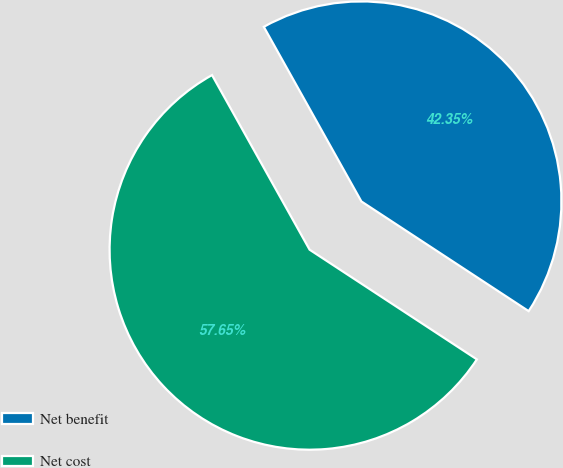<chart> <loc_0><loc_0><loc_500><loc_500><pie_chart><fcel>Net benefit<fcel>Net cost<nl><fcel>42.35%<fcel>57.65%<nl></chart> 